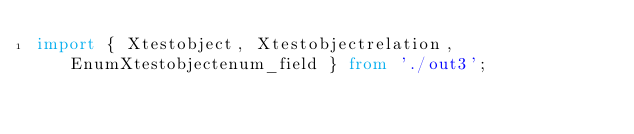<code> <loc_0><loc_0><loc_500><loc_500><_TypeScript_>import { Xtestobject, Xtestobjectrelation, EnumXtestobjectenum_field } from './out3';</code> 